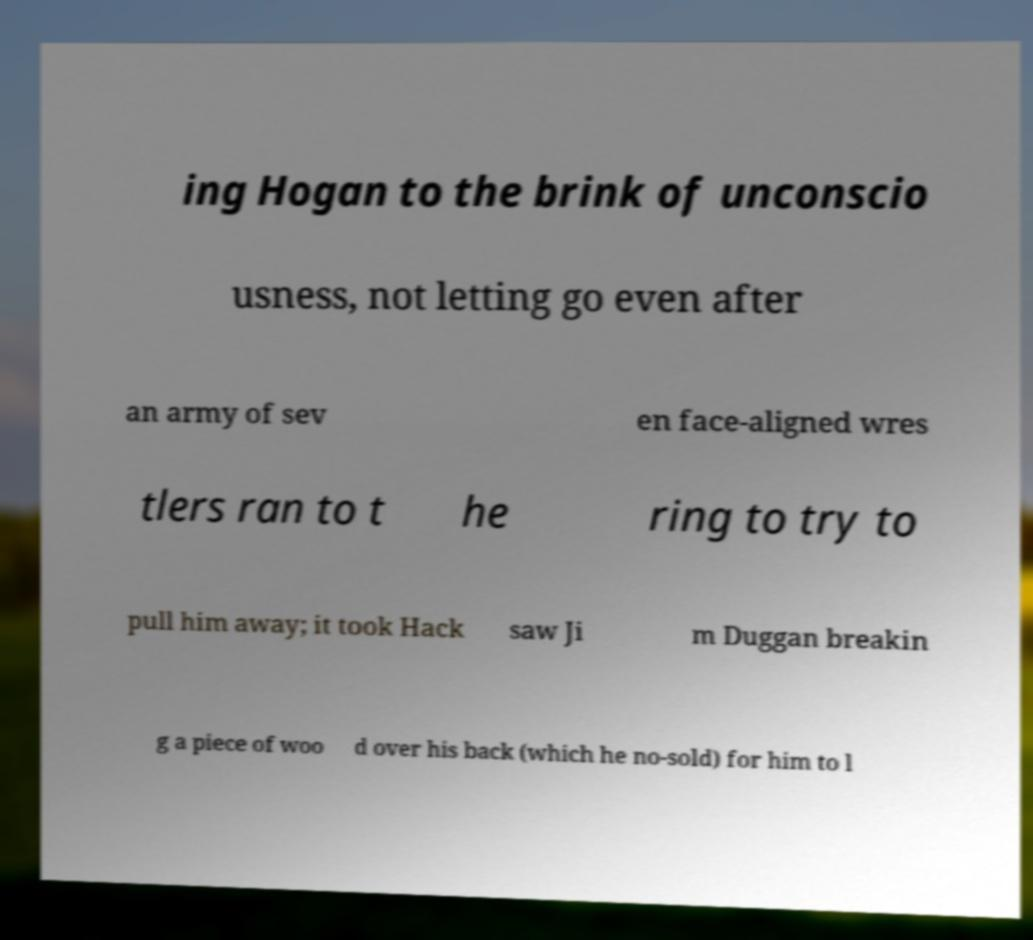Could you extract and type out the text from this image? ing Hogan to the brink of unconscio usness, not letting go even after an army of sev en face-aligned wres tlers ran to t he ring to try to pull him away; it took Hack saw Ji m Duggan breakin g a piece of woo d over his back (which he no-sold) for him to l 